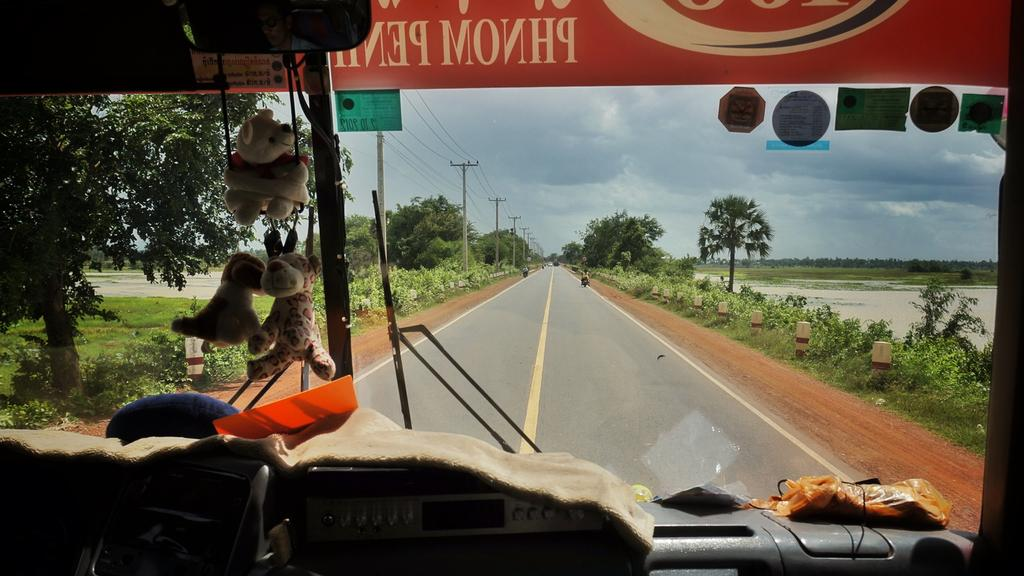What is the main feature of the image? There is a road in the image. What can be seen on either side of the road? There is a water surface on either side of the road. Are there any plants or vegetation near the water surface? Yes, there are trees near the water surface. What is visible in the sky in the background of the image? There are clouds visible in the sky in the background of the image. What type of sound can be heard coming from the yam in the image? There is no yam present in the image, so it is not possible to determine what sound, if any, might be coming from it. 